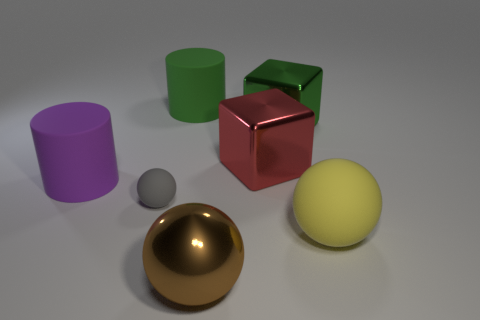What material is the cylinder that is behind the large matte cylinder to the left of the green matte cylinder made of?
Provide a succinct answer. Rubber. What is the material of the object that is both to the right of the big red thing and behind the gray ball?
Give a very brief answer. Metal. Are there any red objects of the same shape as the green metal thing?
Offer a very short reply. Yes. There is a cylinder left of the green cylinder; are there any large matte cylinders that are on the right side of it?
Make the answer very short. Yes. What number of big red blocks have the same material as the purple cylinder?
Provide a short and direct response. 0. Are any green cubes visible?
Your answer should be very brief. Yes. How many small matte objects are the same color as the large metal sphere?
Provide a succinct answer. 0. Is the small gray object made of the same material as the large green object that is to the left of the brown metallic thing?
Your answer should be very brief. Yes. Is the number of large rubber objects that are on the left side of the large yellow rubber sphere greater than the number of large brown shiny things?
Give a very brief answer. Yes. Is there anything else that is the same size as the gray sphere?
Make the answer very short. No. 